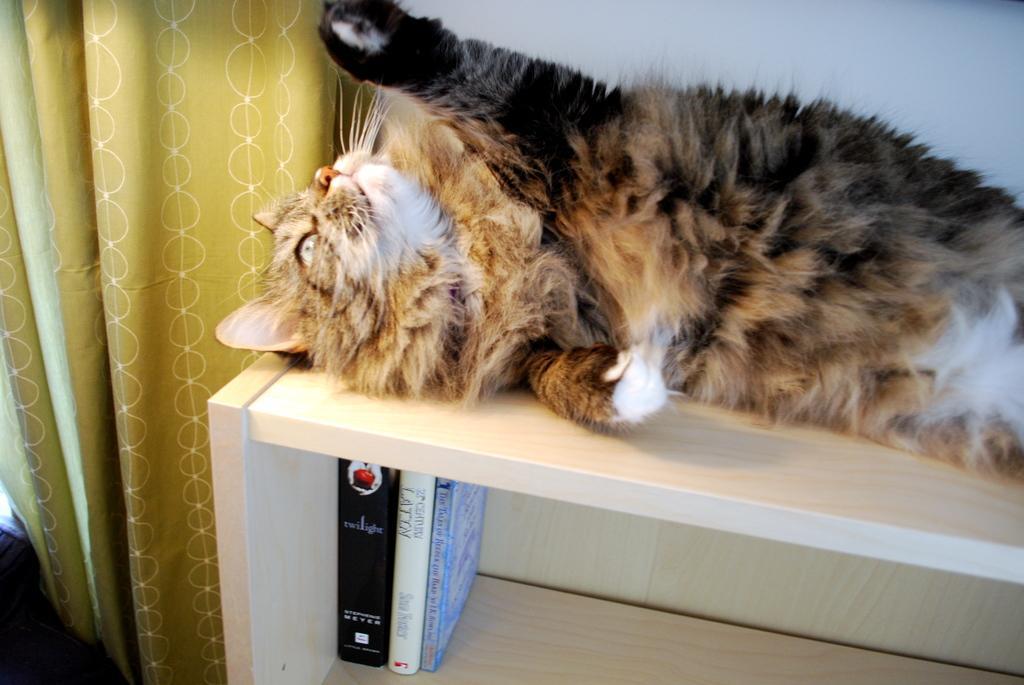Please provide a concise description of this image. In this image I can see a cat laying on a table. There are few books in the table cabinet. On the left side there is a curtain to the wall. 